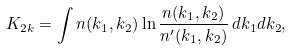<formula> <loc_0><loc_0><loc_500><loc_500>K _ { 2 k } = \int n ( k _ { 1 } , k _ { 2 } ) \ln { \frac { n ( k _ { 1 } , k _ { 2 } ) } { n ^ { \prime } ( k _ { 1 } , k _ { 2 } ) } } \, d k _ { 1 } d k _ { 2 } ,</formula> 